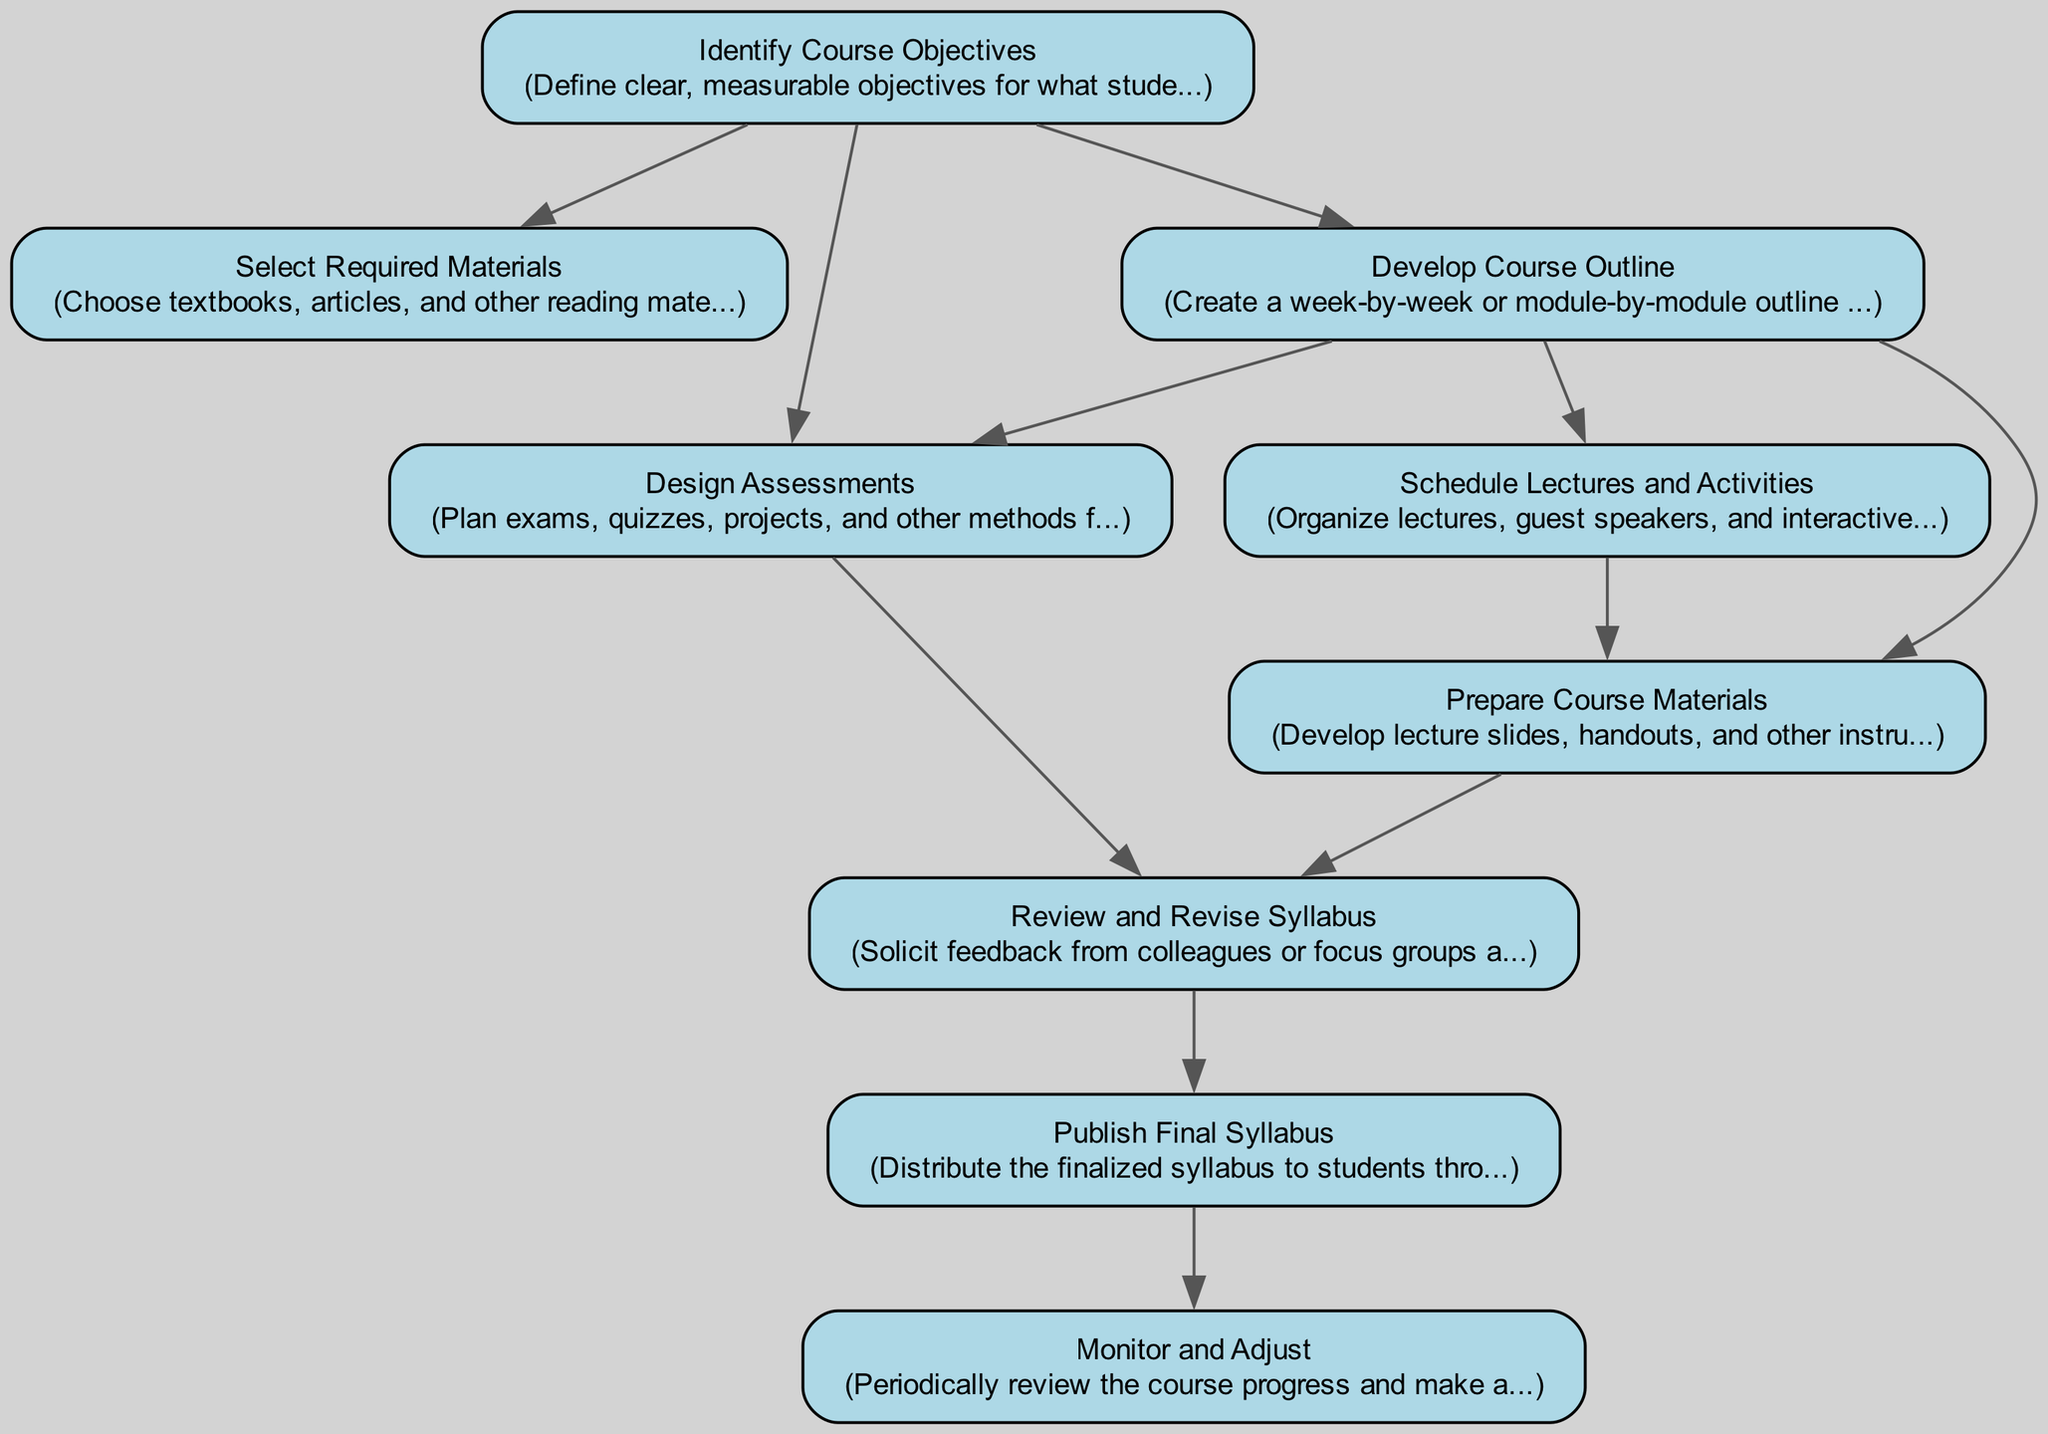What is the first step in course syllabus development? The first step is "Identify Course Objectives", which is the initial action required before any other steps and has no dependencies.
Answer: Identify Course Objectives How many nodes are in the diagram? By counting all unique elements related to the course syllabus development process, we find a total of 9 nodes, each representing a specific step in the flow.
Answer: 9 Which step comes after "Develop Course Outline"? The steps that follow "Develop Course Outline" are "Design Assessments" and "Schedule Lectures and Activities", as both depend on the completion of the outline.
Answer: Design Assessments, Schedule Lectures and Activities What is the final step in the course syllabus development process? The final step in the process is "Monitor and Adjust", which occurs after distributing the finalized syllabus to students.
Answer: Monitor and Adjust Is "Prepare Course Materials" dependent on "Select Required Materials"? "Prepare Course Materials" does not depend on "Select Required Materials." It is dependent on "Develop Course Outline" and "Schedule Lectures and Activities" instead.
Answer: No What are the two dependencies for "Review and Revise Syllabus"? The two dependencies are "Prepare Course Materials" and "Design Assessments," as both must be completed before revisions can occur.
Answer: Prepare Course Materials, Design Assessments What is the connection between "Schedule Lectures and Activities" and "Design Assessments"? "Schedule Lectures and Activities" occurs after "Develop Course Outline," while "Design Assessments" requires both "Identify Course Objectives" and "Develop Course Outline," indicating a sequential, yet parallel structure to these steps.
Answer: They are sequential but independent steps in the process What happens after "Publish Final Syllabus"? After "Publish Final Syllabus," the next action is "Monitor and Adjust," which involves ongoing evaluations and modifications to improve the course experience.
Answer: Monitor and Adjust 